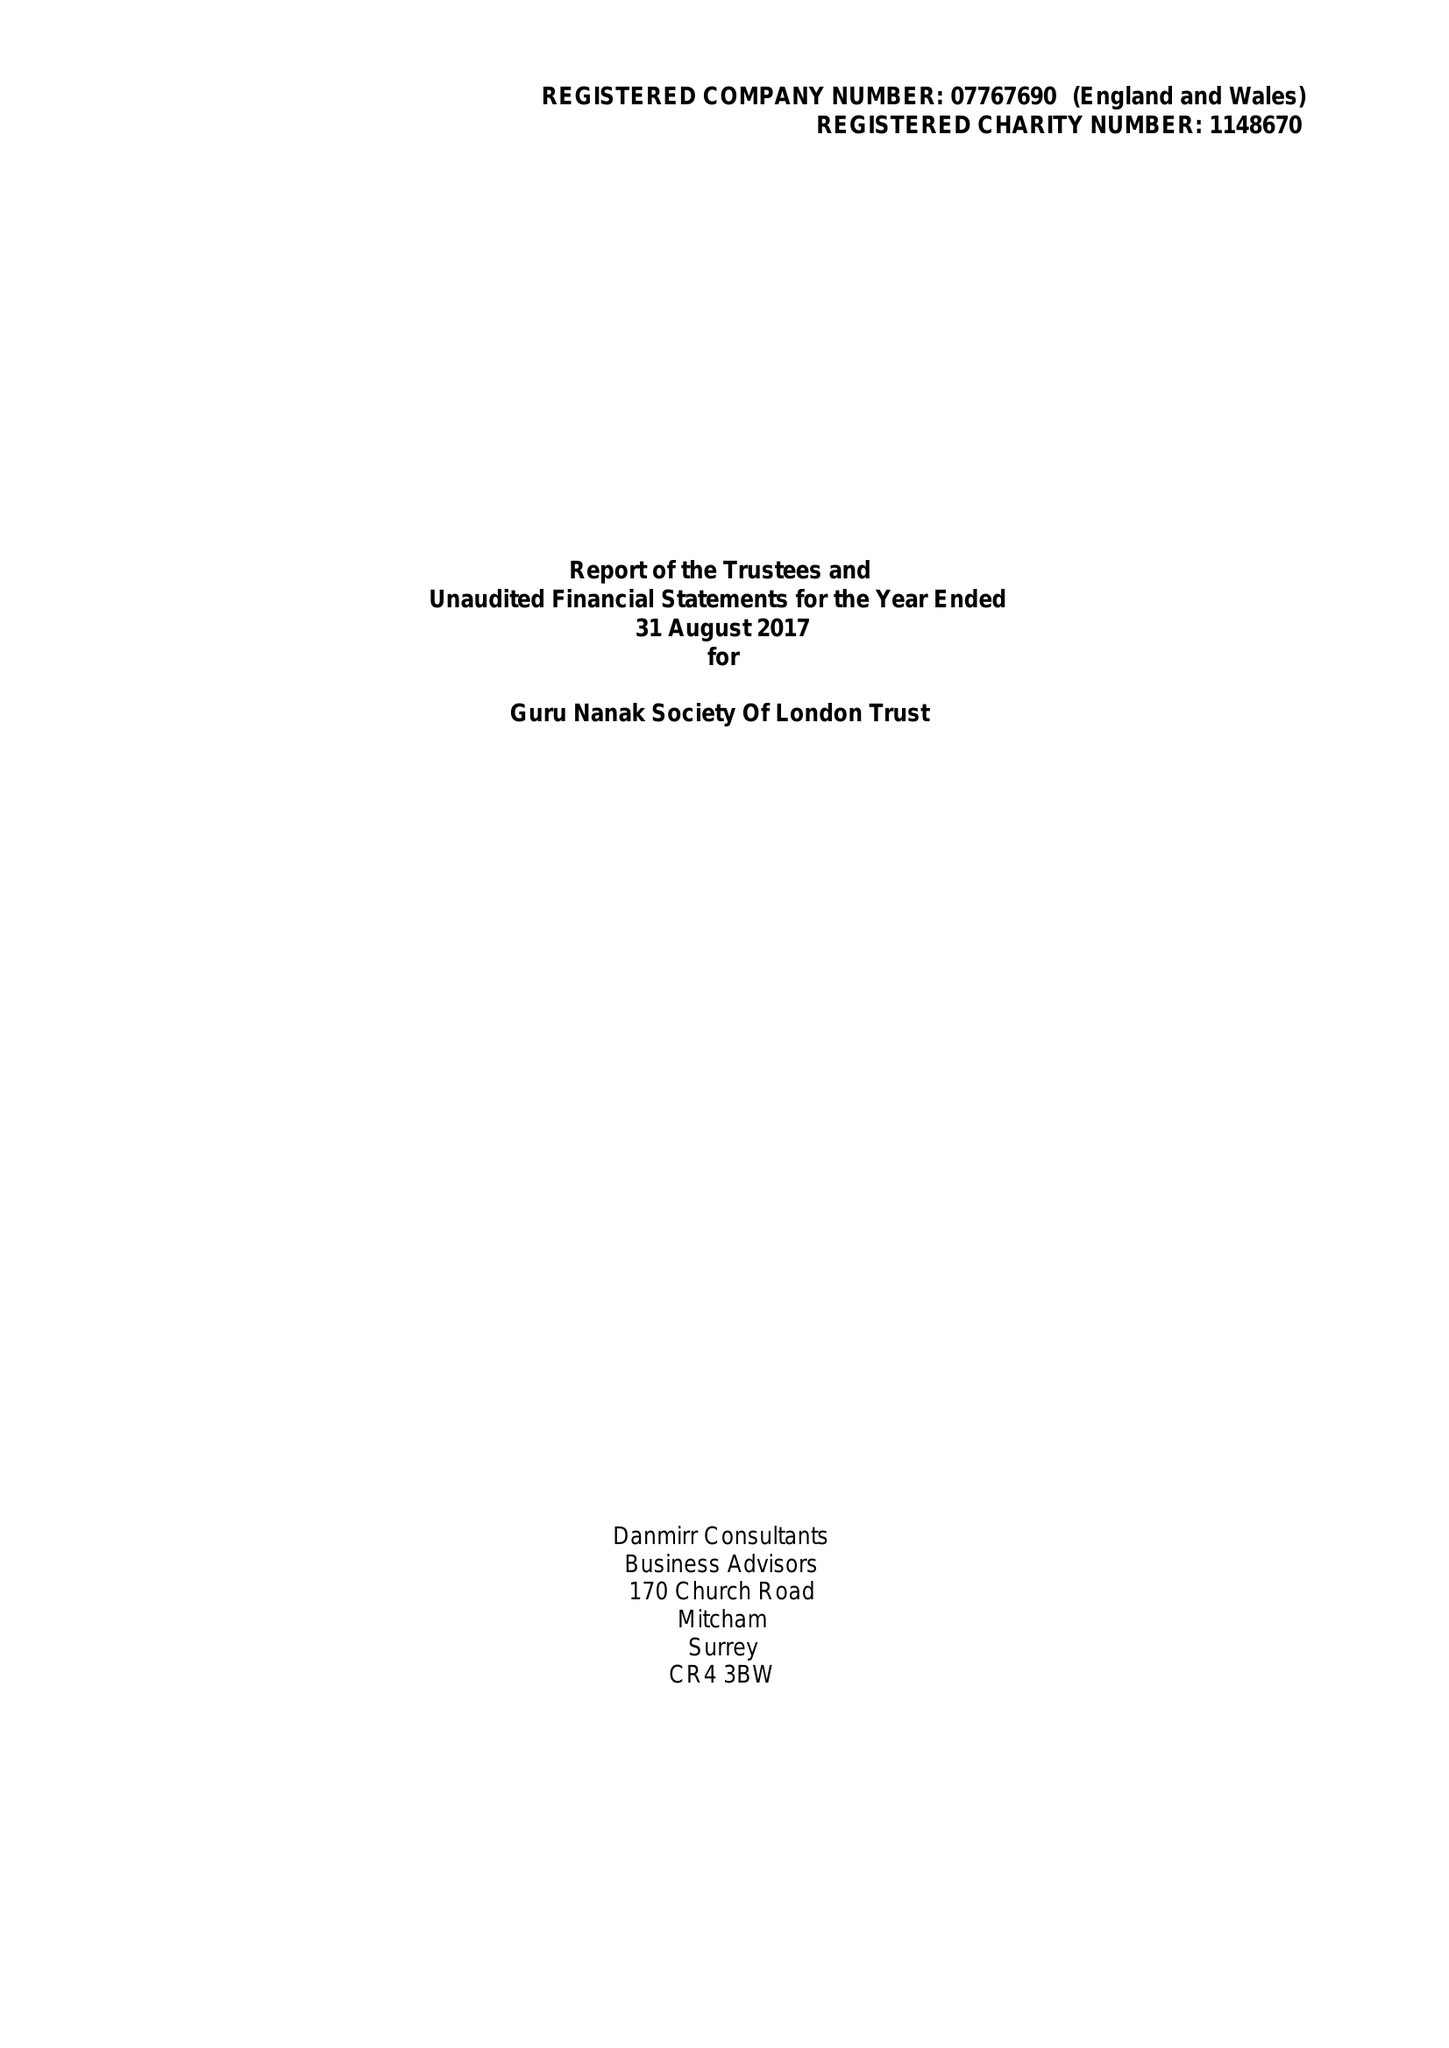What is the value for the income_annually_in_british_pounds?
Answer the question using a single word or phrase. 155264.00 